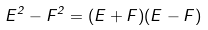<formula> <loc_0><loc_0><loc_500><loc_500>E ^ { 2 } - F ^ { 2 } = ( E + F ) ( E - F )</formula> 